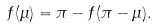Convert formula to latex. <formula><loc_0><loc_0><loc_500><loc_500>f ( \mu ) = \pi - f ( \pi - \mu ) .</formula> 